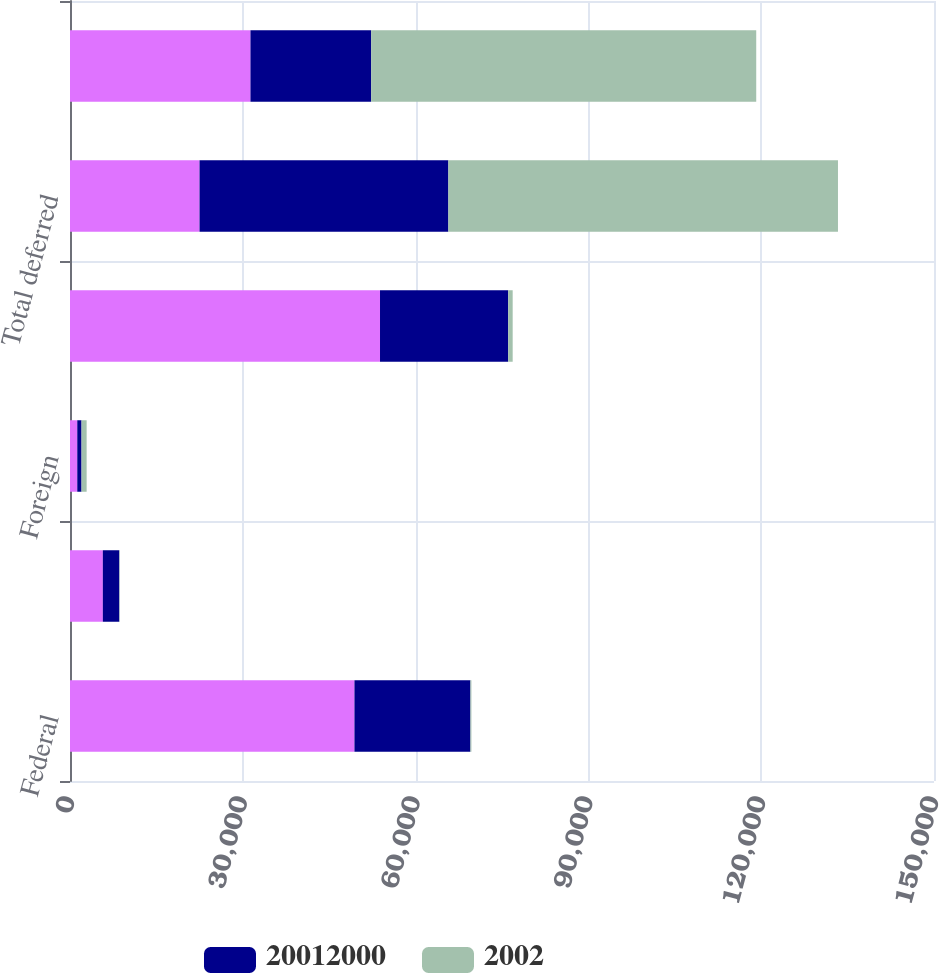Convert chart to OTSL. <chart><loc_0><loc_0><loc_500><loc_500><stacked_bar_chart><ecel><fcel>Federal<fcel>State<fcel>Foreign<fcel>Total current<fcel>Total deferred<fcel>Total income tax expense<nl><fcel>nan<fcel>49384<fcel>5699<fcel>1262<fcel>53821<fcel>22490<fcel>31331<nl><fcel>2.0012e+07<fcel>20129<fcel>2862<fcel>740<fcel>22251<fcel>43199<fcel>20948<nl><fcel>2002<fcel>175<fcel>70<fcel>887<fcel>782<fcel>67640<fcel>66858<nl></chart> 